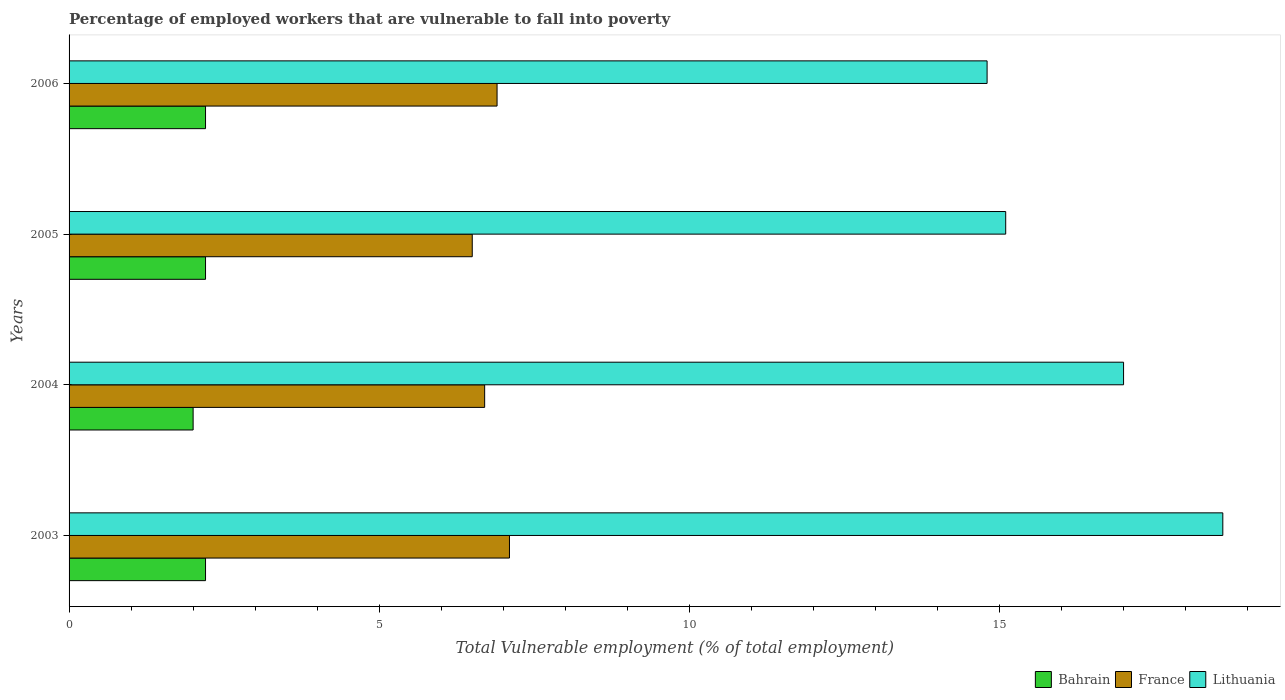How many groups of bars are there?
Offer a very short reply. 4. How many bars are there on the 2nd tick from the top?
Make the answer very short. 3. What is the percentage of employed workers who are vulnerable to fall into poverty in France in 2004?
Provide a short and direct response. 6.7. Across all years, what is the maximum percentage of employed workers who are vulnerable to fall into poverty in Bahrain?
Keep it short and to the point. 2.2. What is the total percentage of employed workers who are vulnerable to fall into poverty in Lithuania in the graph?
Offer a terse response. 65.5. What is the difference between the percentage of employed workers who are vulnerable to fall into poverty in Lithuania in 2003 and that in 2005?
Ensure brevity in your answer.  3.5. What is the difference between the percentage of employed workers who are vulnerable to fall into poverty in France in 2004 and the percentage of employed workers who are vulnerable to fall into poverty in Lithuania in 2003?
Your answer should be very brief. -11.9. What is the average percentage of employed workers who are vulnerable to fall into poverty in France per year?
Your answer should be very brief. 6.8. In the year 2003, what is the difference between the percentage of employed workers who are vulnerable to fall into poverty in Bahrain and percentage of employed workers who are vulnerable to fall into poverty in Lithuania?
Keep it short and to the point. -16.4. What is the ratio of the percentage of employed workers who are vulnerable to fall into poverty in Bahrain in 2003 to that in 2004?
Your answer should be compact. 1.1. Is the difference between the percentage of employed workers who are vulnerable to fall into poverty in Bahrain in 2003 and 2006 greater than the difference between the percentage of employed workers who are vulnerable to fall into poverty in Lithuania in 2003 and 2006?
Your answer should be compact. No. What is the difference between the highest and the second highest percentage of employed workers who are vulnerable to fall into poverty in France?
Keep it short and to the point. 0.2. What is the difference between the highest and the lowest percentage of employed workers who are vulnerable to fall into poverty in France?
Make the answer very short. 0.6. In how many years, is the percentage of employed workers who are vulnerable to fall into poverty in France greater than the average percentage of employed workers who are vulnerable to fall into poverty in France taken over all years?
Your answer should be very brief. 2. Is the sum of the percentage of employed workers who are vulnerable to fall into poverty in Bahrain in 2003 and 2005 greater than the maximum percentage of employed workers who are vulnerable to fall into poverty in Lithuania across all years?
Keep it short and to the point. No. What does the 1st bar from the top in 2005 represents?
Ensure brevity in your answer.  Lithuania. What does the 3rd bar from the bottom in 2006 represents?
Make the answer very short. Lithuania. Is it the case that in every year, the sum of the percentage of employed workers who are vulnerable to fall into poverty in Lithuania and percentage of employed workers who are vulnerable to fall into poverty in Bahrain is greater than the percentage of employed workers who are vulnerable to fall into poverty in France?
Provide a short and direct response. Yes. How many bars are there?
Ensure brevity in your answer.  12. How many years are there in the graph?
Offer a terse response. 4. What is the difference between two consecutive major ticks on the X-axis?
Give a very brief answer. 5. Are the values on the major ticks of X-axis written in scientific E-notation?
Your answer should be very brief. No. Does the graph contain any zero values?
Provide a short and direct response. No. Does the graph contain grids?
Your answer should be very brief. No. Where does the legend appear in the graph?
Provide a short and direct response. Bottom right. How are the legend labels stacked?
Ensure brevity in your answer.  Horizontal. What is the title of the graph?
Provide a short and direct response. Percentage of employed workers that are vulnerable to fall into poverty. Does "Bangladesh" appear as one of the legend labels in the graph?
Provide a short and direct response. No. What is the label or title of the X-axis?
Offer a terse response. Total Vulnerable employment (% of total employment). What is the Total Vulnerable employment (% of total employment) of Bahrain in 2003?
Keep it short and to the point. 2.2. What is the Total Vulnerable employment (% of total employment) of France in 2003?
Provide a short and direct response. 7.1. What is the Total Vulnerable employment (% of total employment) in Lithuania in 2003?
Your response must be concise. 18.6. What is the Total Vulnerable employment (% of total employment) in France in 2004?
Your answer should be compact. 6.7. What is the Total Vulnerable employment (% of total employment) in Bahrain in 2005?
Make the answer very short. 2.2. What is the Total Vulnerable employment (% of total employment) in France in 2005?
Offer a terse response. 6.5. What is the Total Vulnerable employment (% of total employment) of Lithuania in 2005?
Make the answer very short. 15.1. What is the Total Vulnerable employment (% of total employment) in Bahrain in 2006?
Your response must be concise. 2.2. What is the Total Vulnerable employment (% of total employment) in France in 2006?
Your answer should be very brief. 6.9. What is the Total Vulnerable employment (% of total employment) of Lithuania in 2006?
Make the answer very short. 14.8. Across all years, what is the maximum Total Vulnerable employment (% of total employment) of Bahrain?
Make the answer very short. 2.2. Across all years, what is the maximum Total Vulnerable employment (% of total employment) of France?
Your response must be concise. 7.1. Across all years, what is the maximum Total Vulnerable employment (% of total employment) of Lithuania?
Provide a short and direct response. 18.6. Across all years, what is the minimum Total Vulnerable employment (% of total employment) of France?
Give a very brief answer. 6.5. Across all years, what is the minimum Total Vulnerable employment (% of total employment) in Lithuania?
Your answer should be very brief. 14.8. What is the total Total Vulnerable employment (% of total employment) of Bahrain in the graph?
Your answer should be very brief. 8.6. What is the total Total Vulnerable employment (% of total employment) in France in the graph?
Offer a very short reply. 27.2. What is the total Total Vulnerable employment (% of total employment) of Lithuania in the graph?
Your answer should be very brief. 65.5. What is the difference between the Total Vulnerable employment (% of total employment) of Lithuania in 2003 and that in 2004?
Your answer should be very brief. 1.6. What is the difference between the Total Vulnerable employment (% of total employment) of France in 2003 and that in 2006?
Make the answer very short. 0.2. What is the difference between the Total Vulnerable employment (% of total employment) in Lithuania in 2003 and that in 2006?
Give a very brief answer. 3.8. What is the difference between the Total Vulnerable employment (% of total employment) of Bahrain in 2004 and that in 2005?
Your response must be concise. -0.2. What is the difference between the Total Vulnerable employment (% of total employment) of Bahrain in 2004 and that in 2006?
Your answer should be very brief. -0.2. What is the difference between the Total Vulnerable employment (% of total employment) of France in 2004 and that in 2006?
Give a very brief answer. -0.2. What is the difference between the Total Vulnerable employment (% of total employment) in Bahrain in 2005 and that in 2006?
Keep it short and to the point. 0. What is the difference between the Total Vulnerable employment (% of total employment) in France in 2005 and that in 2006?
Ensure brevity in your answer.  -0.4. What is the difference between the Total Vulnerable employment (% of total employment) of Lithuania in 2005 and that in 2006?
Make the answer very short. 0.3. What is the difference between the Total Vulnerable employment (% of total employment) in Bahrain in 2003 and the Total Vulnerable employment (% of total employment) in Lithuania in 2004?
Offer a terse response. -14.8. What is the difference between the Total Vulnerable employment (% of total employment) in France in 2003 and the Total Vulnerable employment (% of total employment) in Lithuania in 2004?
Provide a short and direct response. -9.9. What is the difference between the Total Vulnerable employment (% of total employment) in Bahrain in 2003 and the Total Vulnerable employment (% of total employment) in Lithuania in 2005?
Provide a short and direct response. -12.9. What is the difference between the Total Vulnerable employment (% of total employment) in France in 2003 and the Total Vulnerable employment (% of total employment) in Lithuania in 2005?
Make the answer very short. -8. What is the difference between the Total Vulnerable employment (% of total employment) of Bahrain in 2003 and the Total Vulnerable employment (% of total employment) of Lithuania in 2006?
Give a very brief answer. -12.6. What is the difference between the Total Vulnerable employment (% of total employment) in France in 2003 and the Total Vulnerable employment (% of total employment) in Lithuania in 2006?
Keep it short and to the point. -7.7. What is the difference between the Total Vulnerable employment (% of total employment) of Bahrain in 2004 and the Total Vulnerable employment (% of total employment) of France in 2005?
Your response must be concise. -4.5. What is the difference between the Total Vulnerable employment (% of total employment) in Bahrain in 2004 and the Total Vulnerable employment (% of total employment) in France in 2006?
Offer a terse response. -4.9. What is the difference between the Total Vulnerable employment (% of total employment) in Bahrain in 2005 and the Total Vulnerable employment (% of total employment) in Lithuania in 2006?
Provide a short and direct response. -12.6. What is the average Total Vulnerable employment (% of total employment) in Bahrain per year?
Offer a terse response. 2.15. What is the average Total Vulnerable employment (% of total employment) of France per year?
Provide a short and direct response. 6.8. What is the average Total Vulnerable employment (% of total employment) in Lithuania per year?
Ensure brevity in your answer.  16.38. In the year 2003, what is the difference between the Total Vulnerable employment (% of total employment) of Bahrain and Total Vulnerable employment (% of total employment) of Lithuania?
Provide a succinct answer. -16.4. In the year 2003, what is the difference between the Total Vulnerable employment (% of total employment) in France and Total Vulnerable employment (% of total employment) in Lithuania?
Your response must be concise. -11.5. In the year 2004, what is the difference between the Total Vulnerable employment (% of total employment) in Bahrain and Total Vulnerable employment (% of total employment) in France?
Give a very brief answer. -4.7. In the year 2005, what is the difference between the Total Vulnerable employment (% of total employment) of Bahrain and Total Vulnerable employment (% of total employment) of France?
Ensure brevity in your answer.  -4.3. In the year 2006, what is the difference between the Total Vulnerable employment (% of total employment) in Bahrain and Total Vulnerable employment (% of total employment) in France?
Your response must be concise. -4.7. In the year 2006, what is the difference between the Total Vulnerable employment (% of total employment) in Bahrain and Total Vulnerable employment (% of total employment) in Lithuania?
Your answer should be compact. -12.6. What is the ratio of the Total Vulnerable employment (% of total employment) in Bahrain in 2003 to that in 2004?
Give a very brief answer. 1.1. What is the ratio of the Total Vulnerable employment (% of total employment) of France in 2003 to that in 2004?
Your answer should be compact. 1.06. What is the ratio of the Total Vulnerable employment (% of total employment) in Lithuania in 2003 to that in 2004?
Provide a short and direct response. 1.09. What is the ratio of the Total Vulnerable employment (% of total employment) in Bahrain in 2003 to that in 2005?
Provide a short and direct response. 1. What is the ratio of the Total Vulnerable employment (% of total employment) of France in 2003 to that in 2005?
Your answer should be compact. 1.09. What is the ratio of the Total Vulnerable employment (% of total employment) of Lithuania in 2003 to that in 2005?
Give a very brief answer. 1.23. What is the ratio of the Total Vulnerable employment (% of total employment) of Bahrain in 2003 to that in 2006?
Provide a short and direct response. 1. What is the ratio of the Total Vulnerable employment (% of total employment) of France in 2003 to that in 2006?
Keep it short and to the point. 1.03. What is the ratio of the Total Vulnerable employment (% of total employment) in Lithuania in 2003 to that in 2006?
Offer a terse response. 1.26. What is the ratio of the Total Vulnerable employment (% of total employment) of Bahrain in 2004 to that in 2005?
Your answer should be compact. 0.91. What is the ratio of the Total Vulnerable employment (% of total employment) in France in 2004 to that in 2005?
Offer a very short reply. 1.03. What is the ratio of the Total Vulnerable employment (% of total employment) in Lithuania in 2004 to that in 2005?
Your answer should be compact. 1.13. What is the ratio of the Total Vulnerable employment (% of total employment) of France in 2004 to that in 2006?
Provide a succinct answer. 0.97. What is the ratio of the Total Vulnerable employment (% of total employment) in Lithuania in 2004 to that in 2006?
Ensure brevity in your answer.  1.15. What is the ratio of the Total Vulnerable employment (% of total employment) of Bahrain in 2005 to that in 2006?
Keep it short and to the point. 1. What is the ratio of the Total Vulnerable employment (% of total employment) of France in 2005 to that in 2006?
Give a very brief answer. 0.94. What is the ratio of the Total Vulnerable employment (% of total employment) of Lithuania in 2005 to that in 2006?
Your answer should be very brief. 1.02. What is the difference between the highest and the second highest Total Vulnerable employment (% of total employment) in Bahrain?
Offer a very short reply. 0. What is the difference between the highest and the second highest Total Vulnerable employment (% of total employment) of Lithuania?
Your response must be concise. 1.6. What is the difference between the highest and the lowest Total Vulnerable employment (% of total employment) in Bahrain?
Provide a succinct answer. 0.2. 